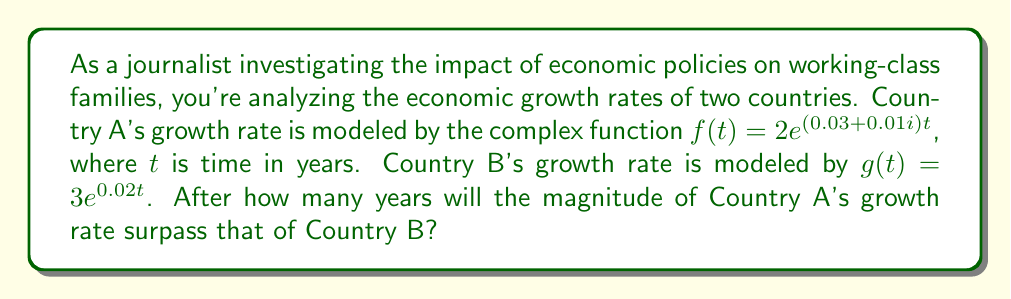Teach me how to tackle this problem. To solve this problem, we need to follow these steps:

1) The magnitude of a complex exponential function $ae^{(b+ci)t}$ is given by $|ae^{(b+ci)t}| = ae^{bt}$.

2) For Country A: $|f(t)| = 2e^{0.03t}$
   For Country B: $|g(t)| = 3e^{0.02t}$

3) We need to find $t$ when $|f(t)| > |g(t)|$:

   $2e^{0.03t} > 3e^{0.02t}$

4) Taking natural logarithm of both sides:

   $\ln(2) + 0.03t > \ln(3) + 0.02t$

5) Simplifying:

   $0.03t - 0.02t > \ln(3) - \ln(2)$
   $0.01t > \ln(1.5)$

6) Solving for $t$:

   $t > \frac{\ln(1.5)}{0.01} \approx 40.55$ years

7) Since we're dealing with whole years, we round up to the next integer.
Answer: The magnitude of Country A's growth rate will surpass that of Country B after 41 years. 